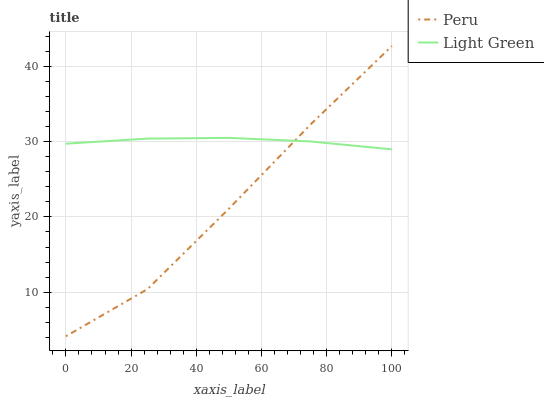Does Peru have the minimum area under the curve?
Answer yes or no. Yes. Does Light Green have the maximum area under the curve?
Answer yes or no. Yes. Does Peru have the maximum area under the curve?
Answer yes or no. No. Is Light Green the smoothest?
Answer yes or no. Yes. Is Peru the roughest?
Answer yes or no. Yes. Is Peru the smoothest?
Answer yes or no. No. Does Peru have the lowest value?
Answer yes or no. Yes. Does Peru have the highest value?
Answer yes or no. Yes. Does Light Green intersect Peru?
Answer yes or no. Yes. Is Light Green less than Peru?
Answer yes or no. No. Is Light Green greater than Peru?
Answer yes or no. No. 